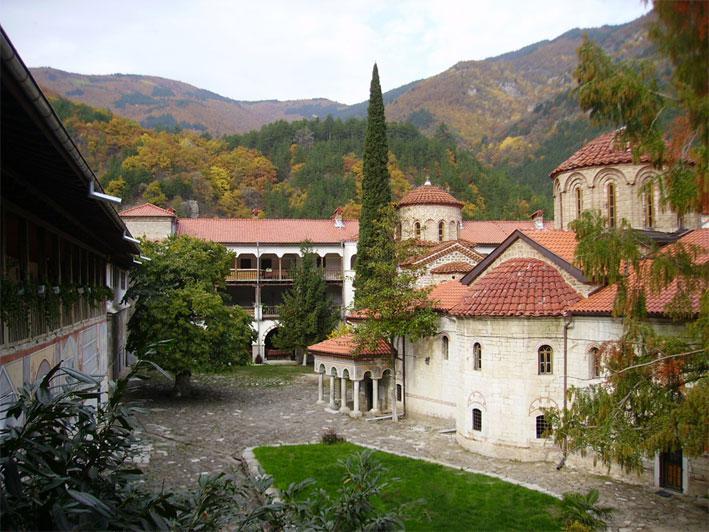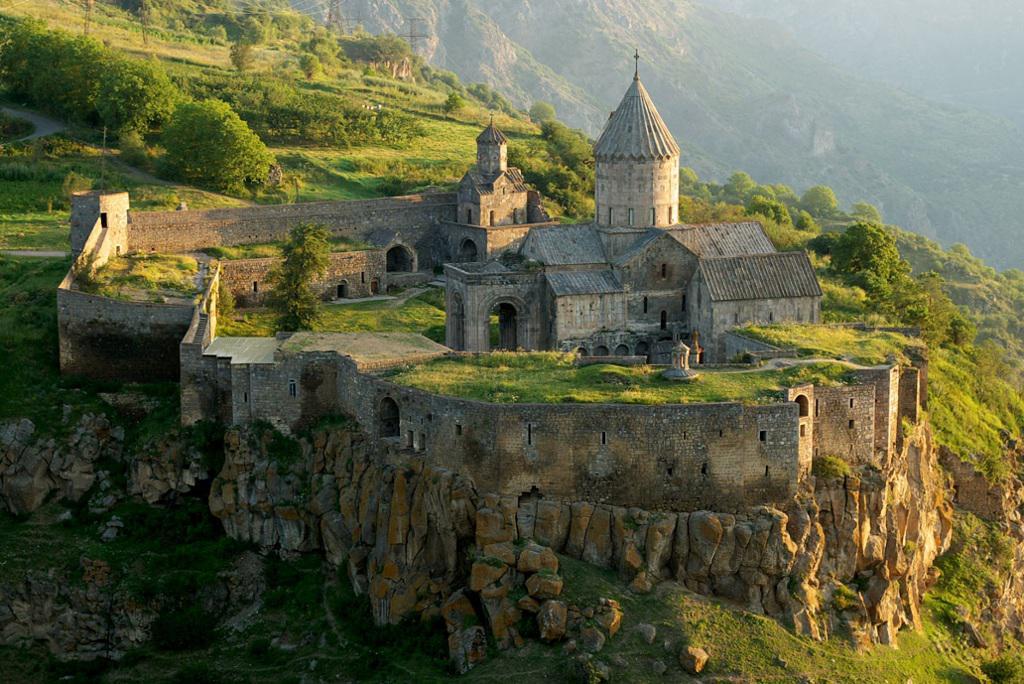The first image is the image on the left, the second image is the image on the right. For the images shown, is this caption "There is a rocky cliff in at least one image." true? Answer yes or no. Yes. 